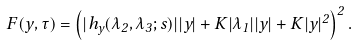<formula> <loc_0><loc_0><loc_500><loc_500>F ( y , \tau ) = \left ( | h _ { y } ( \lambda _ { 2 } , \lambda _ { 3 } ; s ) | | y | + K | \lambda _ { 1 } | | y | + K | y | ^ { 2 } \right ) ^ { 2 } .</formula> 